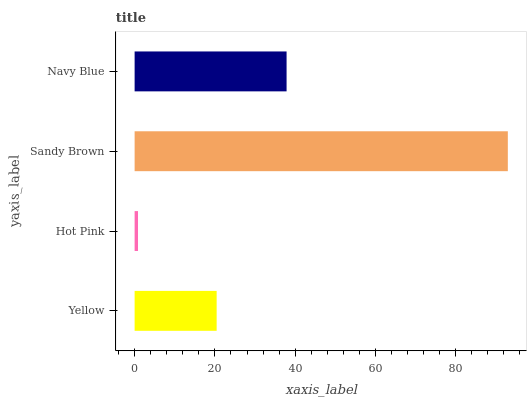Is Hot Pink the minimum?
Answer yes or no. Yes. Is Sandy Brown the maximum?
Answer yes or no. Yes. Is Sandy Brown the minimum?
Answer yes or no. No. Is Hot Pink the maximum?
Answer yes or no. No. Is Sandy Brown greater than Hot Pink?
Answer yes or no. Yes. Is Hot Pink less than Sandy Brown?
Answer yes or no. Yes. Is Hot Pink greater than Sandy Brown?
Answer yes or no. No. Is Sandy Brown less than Hot Pink?
Answer yes or no. No. Is Navy Blue the high median?
Answer yes or no. Yes. Is Yellow the low median?
Answer yes or no. Yes. Is Hot Pink the high median?
Answer yes or no. No. Is Navy Blue the low median?
Answer yes or no. No. 